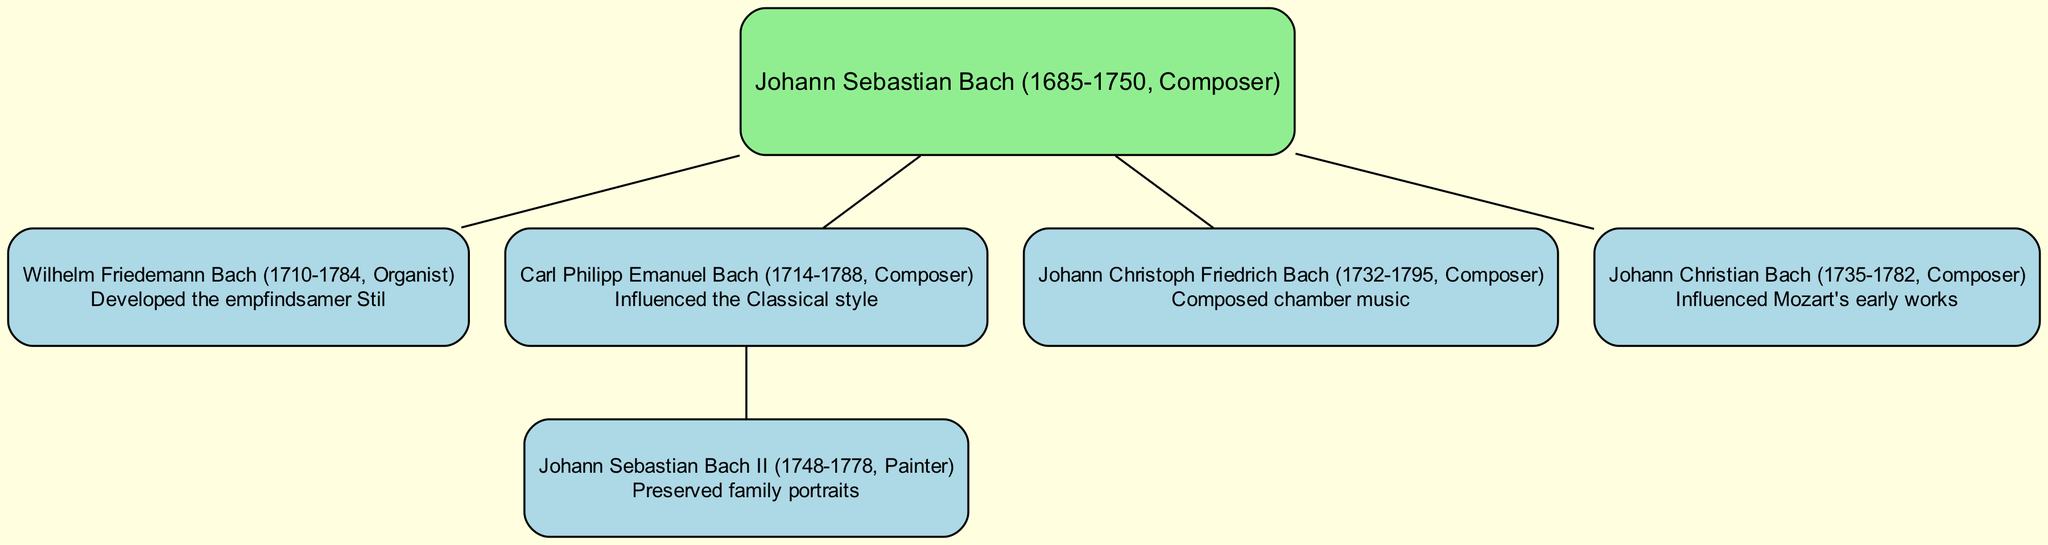What is the main contribution of Johann Sebastian Bach? The diagram indicates that Johann Sebastian Bach is a composer without a specific contribution mentioned beside his name, but it is known historically that he contributed significantly to music overall.
Answer: Composer How many children did Johann Sebastian Bach have? By observing the diagram, Johann Sebastian Bach has four children listed in the family tree.
Answer: 4 Who developed the empfindsamer Stil? Looking at the contributions listed in the diagram, Wilhelm Friedemann Bach is noted for developing the empfindsamer Stil.
Answer: Wilhelm Friedemann Bach Which member influenced Mozart's early works? Referring to the contributions displayed, Johann Christian Bach is highlighted as having influenced Mozart's early works.
Answer: Johann Christian Bach What did Carl Philipp Emanuel Bach influence? The diagram shows that Carl Philipp Emanuel Bach influenced the Classical style, which is a key point in his contribution.
Answer: Classical style Who preserved family portraits? The diagram indicates that Johann Sebastian Bach II was responsible for preserving family portraits, as mentioned in his contribution.
Answer: Johann Sebastian Bach II Which sibling composed chamber music? Upon reviewing the contributions, it is evident that Johann Christoph Friedrich Bach is identified as the one who composed chamber music.
Answer: Johann Christoph Friedrich Bach What is the relationship between Johann Christian Bach and Johann Sebastian Bach? By analyzing the family tree structure, Johann Christian Bach is one of the children of Johann Sebastian Bach.
Answer: Child How many generations are represented in this family tree? The diagram displays two generations: Johann Sebastian Bach as the root and his children as the first generation.
Answer: 2 